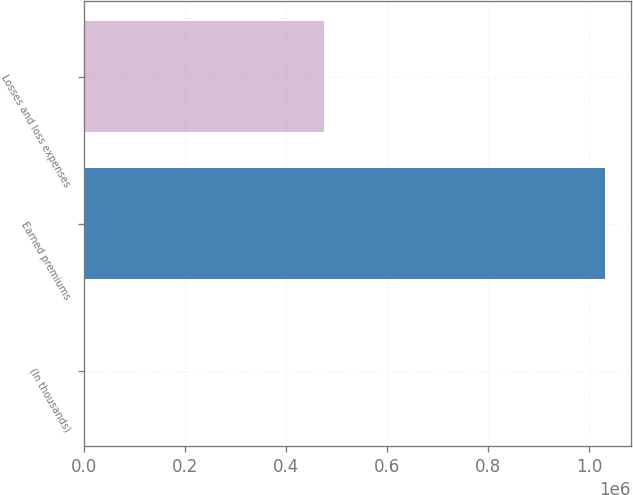Convert chart to OTSL. <chart><loc_0><loc_0><loc_500><loc_500><bar_chart><fcel>(In thousands)<fcel>Earned premiums<fcel>Losses and loss expenses<nl><fcel>2014<fcel>1.03067e+06<fcel>475802<nl></chart> 